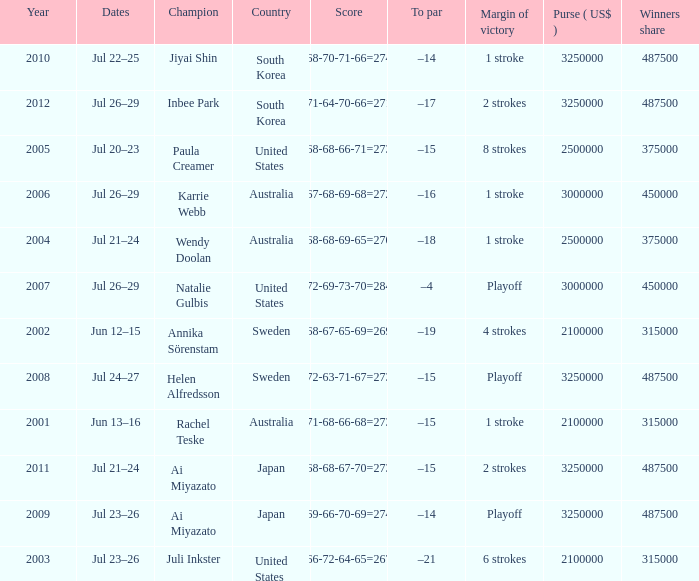Would you be able to parse every entry in this table? {'header': ['Year', 'Dates', 'Champion', 'Country', 'Score', 'To par', 'Margin of victory', 'Purse ( US$ )', 'Winners share'], 'rows': [['2010', 'Jul 22–25', 'Jiyai Shin', 'South Korea', '68-70-71-66=274', '–14', '1 stroke', '3250000', '487500'], ['2012', 'Jul 26–29', 'Inbee Park', 'South Korea', '71-64-70-66=271', '–17', '2 strokes', '3250000', '487500'], ['2005', 'Jul 20–23', 'Paula Creamer', 'United States', '68-68-66-71=273', '–15', '8 strokes', '2500000', '375000'], ['2006', 'Jul 26–29', 'Karrie Webb', 'Australia', '67-68-69-68=272', '–16', '1 stroke', '3000000', '450000'], ['2004', 'Jul 21–24', 'Wendy Doolan', 'Australia', '68-68-69-65=270', '–18', '1 stroke', '2500000', '375000'], ['2007', 'Jul 26–29', 'Natalie Gulbis', 'United States', '72-69-73-70=284', '–4', 'Playoff', '3000000', '450000'], ['2002', 'Jun 12–15', 'Annika Sörenstam', 'Sweden', '68-67-65-69=269', '–19', '4 strokes', '2100000', '315000'], ['2008', 'Jul 24–27', 'Helen Alfredsson', 'Sweden', '72-63-71-67=273', '–15', 'Playoff', '3250000', '487500'], ['2001', 'Jun 13–16', 'Rachel Teske', 'Australia', '71-68-66-68=273', '–15', '1 stroke', '2100000', '315000'], ['2011', 'Jul 21–24', 'Ai Miyazato', 'Japan', '68-68-67-70=273', '–15', '2 strokes', '3250000', '487500'], ['2009', 'Jul 23–26', 'Ai Miyazato', 'Japan', '69-66-70-69=274', '–14', 'Playoff', '3250000', '487500'], ['2003', 'Jul 23–26', 'Juli Inkster', 'United States', '66-72-64-65=267', '–21', '6 strokes', '2100000', '315000']]} What is the lowest year listed? 2001.0. 